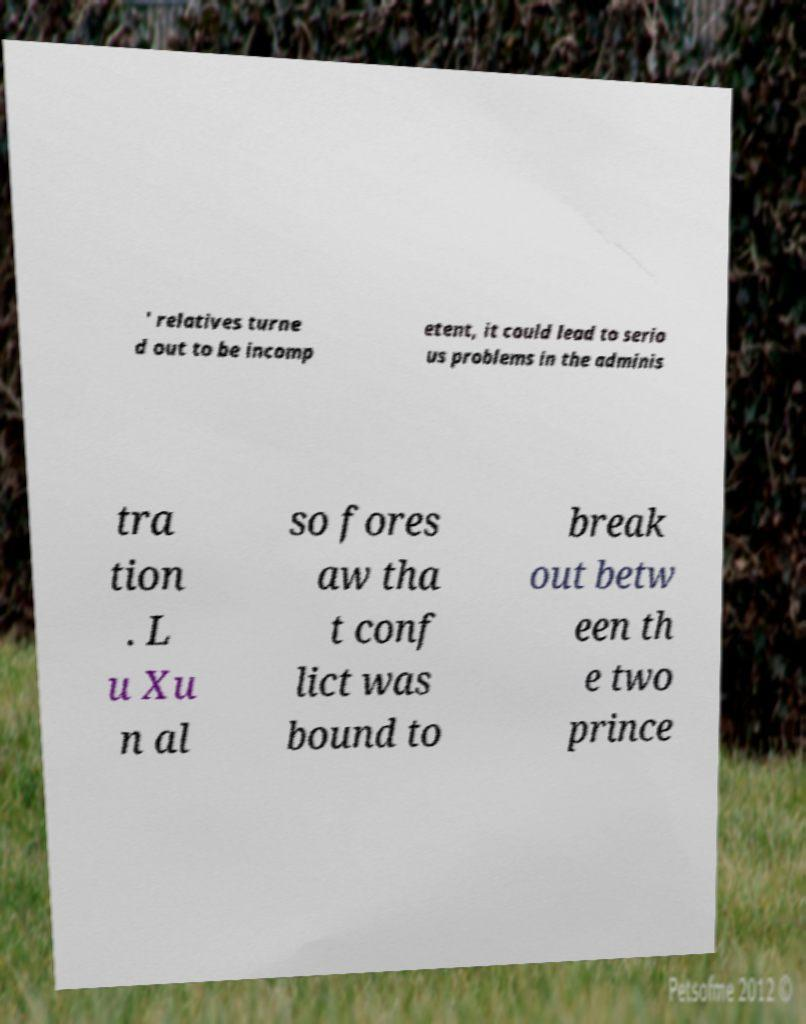What messages or text are displayed in this image? I need them in a readable, typed format. ' relatives turne d out to be incomp etent, it could lead to serio us problems in the adminis tra tion . L u Xu n al so fores aw tha t conf lict was bound to break out betw een th e two prince 